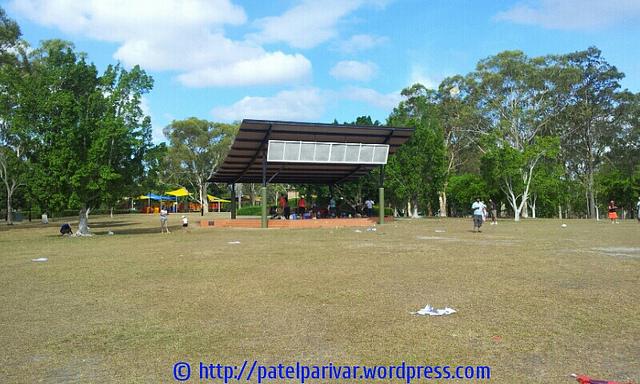What is the color of water?
Write a very short answer. No water. Is there sand?
Concise answer only. No. What color is the sky?
Write a very short answer. Blue. Is it raining?
Keep it brief. No. Are there any clouds in the sky?
Give a very brief answer. Yes. What kind of trees are they?
Write a very short answer. Oak. Are the young children flying a kite?
Keep it brief. No. What are the people standing under?
Concise answer only. Pavillion. Is this a European house?
Answer briefly. No. 